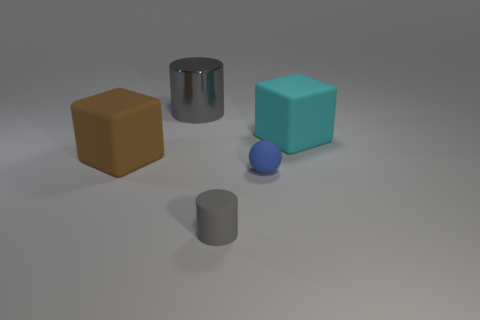Are there any other things that are the same material as the big cylinder?
Your response must be concise. No. What material is the block to the right of the large gray metal thing to the left of the big cyan rubber cube?
Keep it short and to the point. Rubber. There is a tiny rubber object that is the same color as the big cylinder; what is its shape?
Provide a short and direct response. Cylinder. Are there any tiny spheres that have the same material as the large gray object?
Your answer should be compact. No. What shape is the brown rubber thing?
Give a very brief answer. Cube. What number of gray matte cylinders are there?
Your answer should be compact. 1. What color is the matte object behind the big matte cube left of the gray shiny thing?
Make the answer very short. Cyan. The metal object that is the same size as the cyan rubber object is what color?
Your answer should be compact. Gray. Is there a matte thing that has the same color as the metallic cylinder?
Your response must be concise. Yes. Are any large metallic things visible?
Offer a very short reply. Yes. 